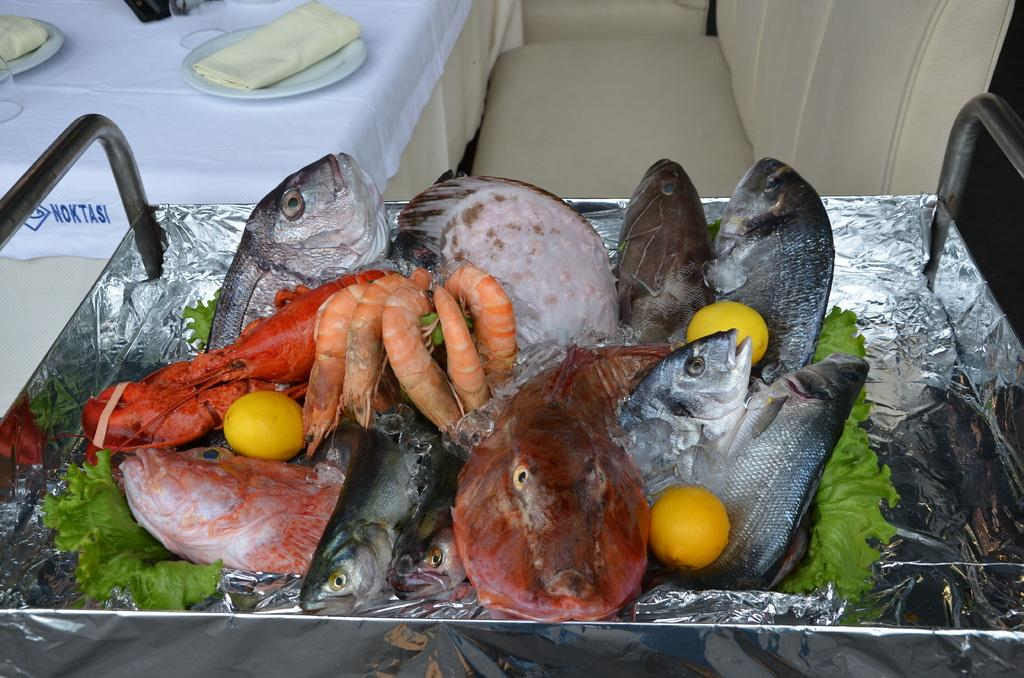What type of food is on the platform in the image? There is sea food on a platform in the image. What type of furniture is in the image? There is a sofa and a table in the image. What is on the table in the image? There is a cloth, plates, clothes, and glasses on the table in the image. What scientific experiment is being conducted on the seashore in the image? There is no scientific experiment or seashore present in the image; it features sea food on a platform, a sofa, a table, and various objects on the table. 